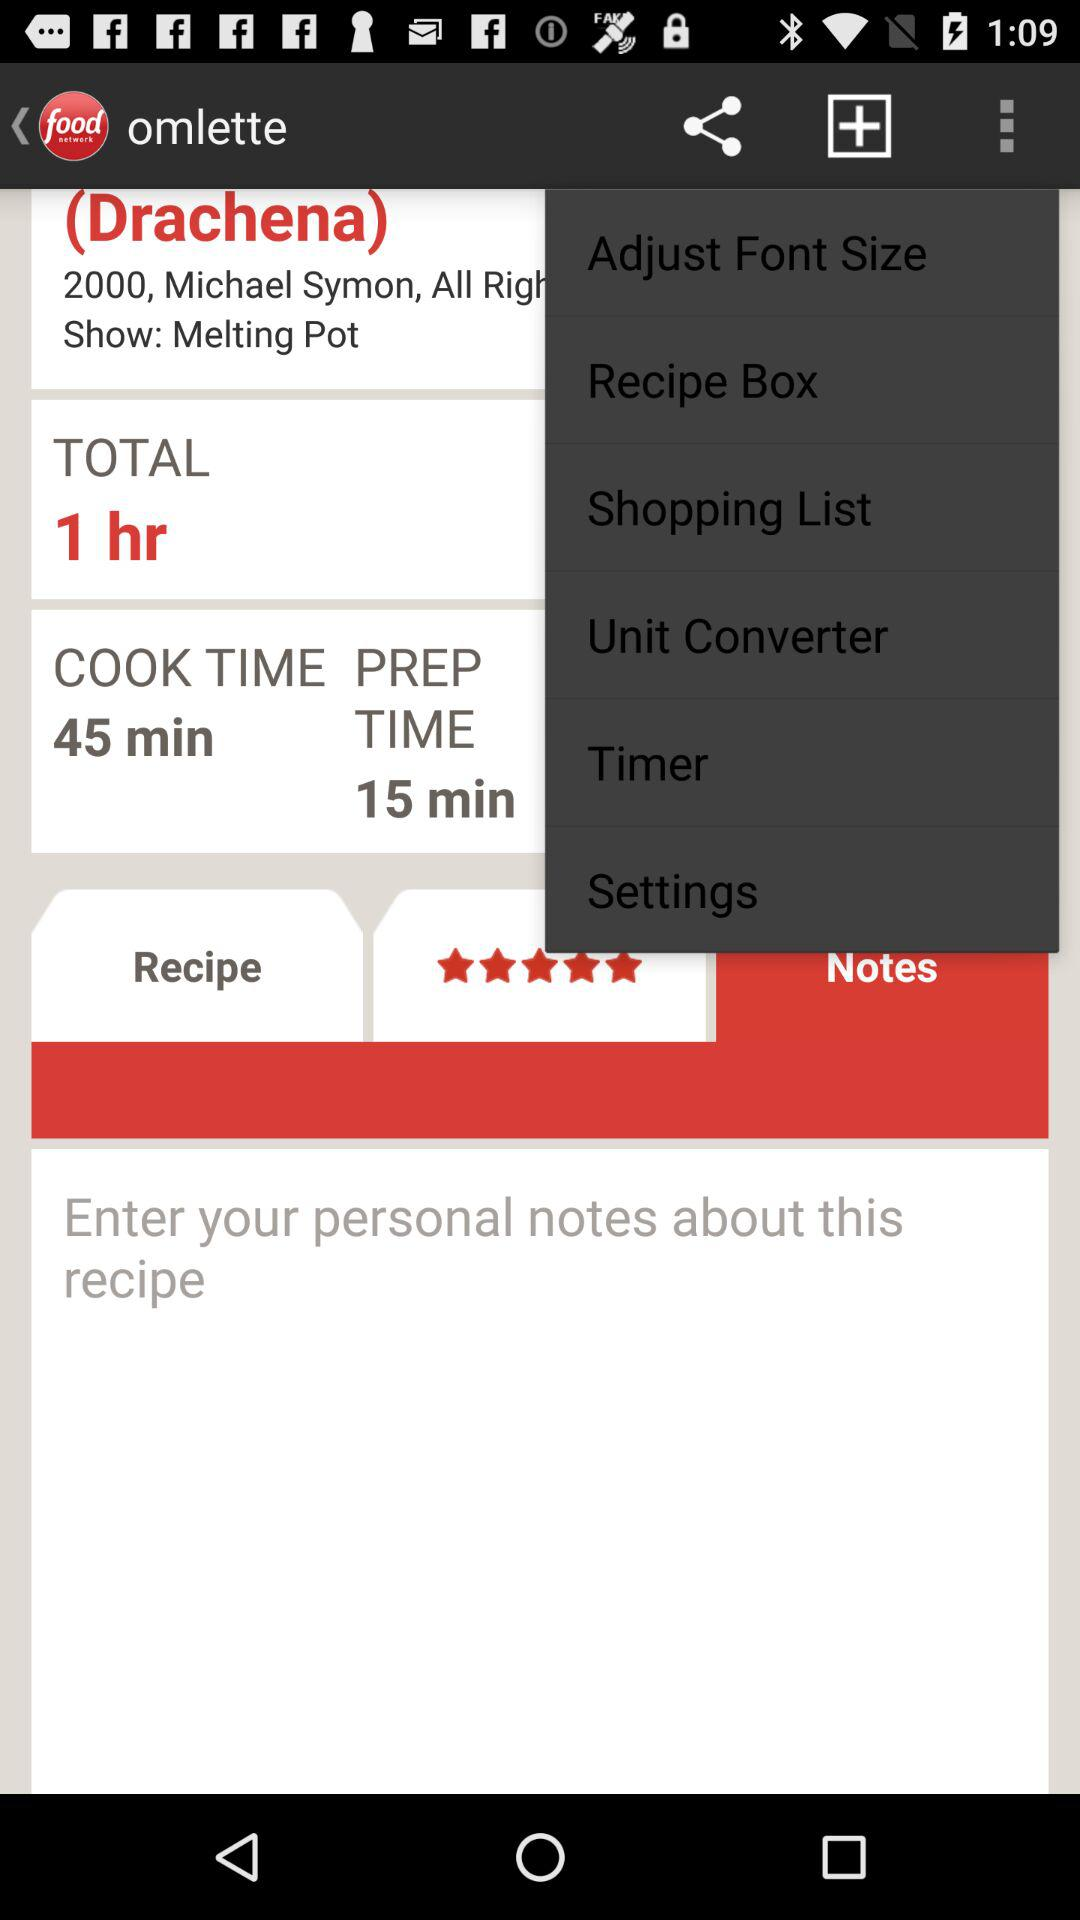Which option is selected in the drop-down menu?
When the provided information is insufficient, respond with <no answer>. <no answer> 